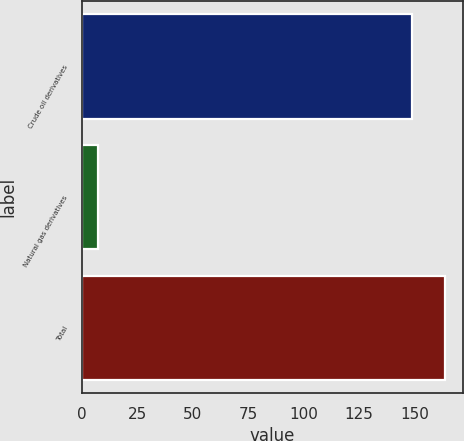<chart> <loc_0><loc_0><loc_500><loc_500><bar_chart><fcel>Crude oil derivatives<fcel>Natural gas derivatives<fcel>Total<nl><fcel>149<fcel>7<fcel>163.9<nl></chart> 